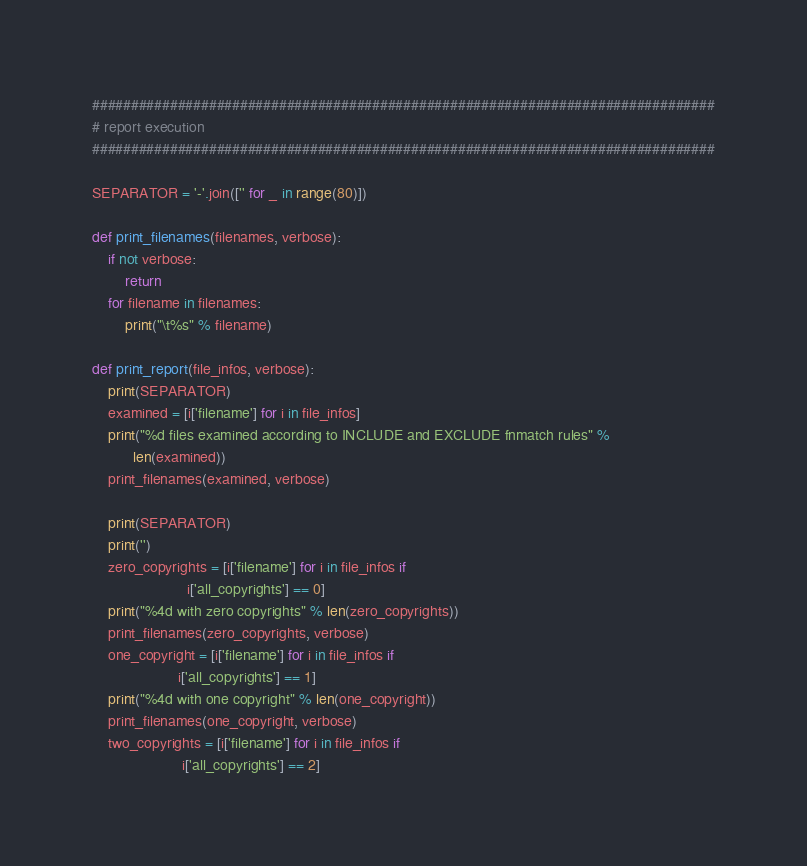<code> <loc_0><loc_0><loc_500><loc_500><_Python_>
################################################################################
# report execution
################################################################################

SEPARATOR = '-'.join(['' for _ in range(80)])

def print_filenames(filenames, verbose):
    if not verbose:
        return
    for filename in filenames:
        print("\t%s" % filename)

def print_report(file_infos, verbose):
    print(SEPARATOR)
    examined = [i['filename'] for i in file_infos]
    print("%d files examined according to INCLUDE and EXCLUDE fnmatch rules" %
          len(examined))
    print_filenames(examined, verbose)

    print(SEPARATOR)
    print('')
    zero_copyrights = [i['filename'] for i in file_infos if
                       i['all_copyrights'] == 0]
    print("%4d with zero copyrights" % len(zero_copyrights))
    print_filenames(zero_copyrights, verbose)
    one_copyright = [i['filename'] for i in file_infos if
                     i['all_copyrights'] == 1]
    print("%4d with one copyright" % len(one_copyright))
    print_filenames(one_copyright, verbose)
    two_copyrights = [i['filename'] for i in file_infos if
                      i['all_copyrights'] == 2]</code> 